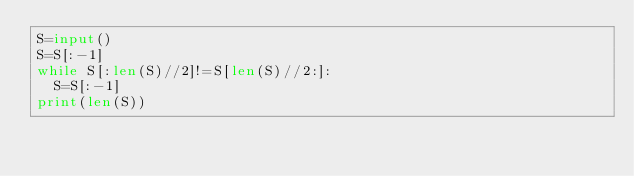Convert code to text. <code><loc_0><loc_0><loc_500><loc_500><_Python_>S=input()
S=S[:-1]
while S[:len(S)//2]!=S[len(S)//2:]:
  S=S[:-1]
print(len(S))</code> 